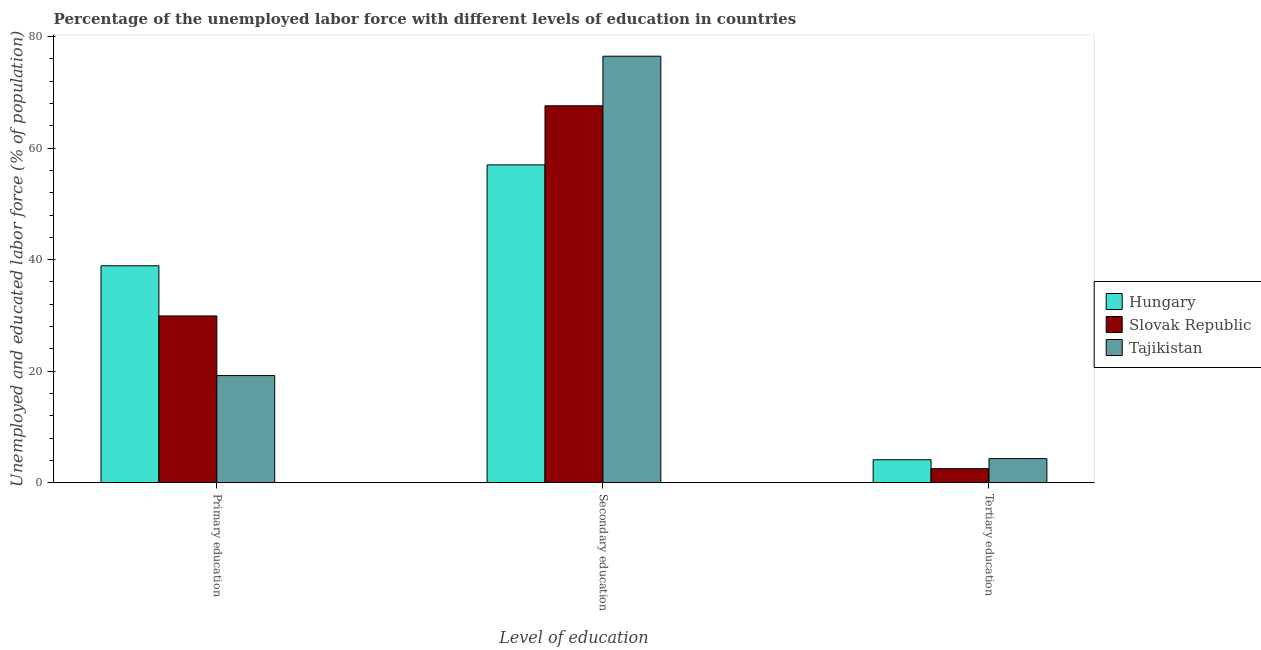Are the number of bars on each tick of the X-axis equal?
Provide a succinct answer. Yes. How many bars are there on the 2nd tick from the left?
Give a very brief answer. 3. How many bars are there on the 2nd tick from the right?
Give a very brief answer. 3. What is the label of the 1st group of bars from the left?
Provide a succinct answer. Primary education. What is the percentage of labor force who received primary education in Tajikistan?
Make the answer very short. 19.2. Across all countries, what is the maximum percentage of labor force who received primary education?
Make the answer very short. 38.9. Across all countries, what is the minimum percentage of labor force who received tertiary education?
Provide a short and direct response. 2.5. In which country was the percentage of labor force who received primary education maximum?
Your answer should be compact. Hungary. In which country was the percentage of labor force who received secondary education minimum?
Make the answer very short. Hungary. What is the total percentage of labor force who received secondary education in the graph?
Offer a terse response. 201.1. What is the difference between the percentage of labor force who received primary education in Hungary and that in Slovak Republic?
Your answer should be compact. 9. What is the difference between the percentage of labor force who received tertiary education in Slovak Republic and the percentage of labor force who received secondary education in Hungary?
Offer a terse response. -54.5. What is the average percentage of labor force who received tertiary education per country?
Your answer should be compact. 3.63. What is the difference between the percentage of labor force who received tertiary education and percentage of labor force who received secondary education in Hungary?
Offer a very short reply. -52.9. In how many countries, is the percentage of labor force who received tertiary education greater than 48 %?
Provide a short and direct response. 0. What is the ratio of the percentage of labor force who received tertiary education in Tajikistan to that in Hungary?
Your response must be concise. 1.05. Is the percentage of labor force who received tertiary education in Tajikistan less than that in Slovak Republic?
Your answer should be very brief. No. Is the difference between the percentage of labor force who received tertiary education in Tajikistan and Slovak Republic greater than the difference between the percentage of labor force who received primary education in Tajikistan and Slovak Republic?
Your answer should be compact. Yes. What is the difference between the highest and the second highest percentage of labor force who received secondary education?
Provide a short and direct response. 8.9. What is the difference between the highest and the lowest percentage of labor force who received primary education?
Your response must be concise. 19.7. Is the sum of the percentage of labor force who received primary education in Hungary and Slovak Republic greater than the maximum percentage of labor force who received tertiary education across all countries?
Provide a short and direct response. Yes. What does the 1st bar from the left in Secondary education represents?
Make the answer very short. Hungary. What does the 1st bar from the right in Tertiary education represents?
Your response must be concise. Tajikistan. How many countries are there in the graph?
Provide a short and direct response. 3. Does the graph contain any zero values?
Your response must be concise. No. Where does the legend appear in the graph?
Make the answer very short. Center right. How many legend labels are there?
Provide a succinct answer. 3. What is the title of the graph?
Give a very brief answer. Percentage of the unemployed labor force with different levels of education in countries. What is the label or title of the X-axis?
Your answer should be very brief. Level of education. What is the label or title of the Y-axis?
Offer a terse response. Unemployed and educated labor force (% of population). What is the Unemployed and educated labor force (% of population) in Hungary in Primary education?
Give a very brief answer. 38.9. What is the Unemployed and educated labor force (% of population) of Slovak Republic in Primary education?
Make the answer very short. 29.9. What is the Unemployed and educated labor force (% of population) of Tajikistan in Primary education?
Your response must be concise. 19.2. What is the Unemployed and educated labor force (% of population) in Slovak Republic in Secondary education?
Provide a short and direct response. 67.6. What is the Unemployed and educated labor force (% of population) in Tajikistan in Secondary education?
Offer a very short reply. 76.5. What is the Unemployed and educated labor force (% of population) in Hungary in Tertiary education?
Your response must be concise. 4.1. What is the Unemployed and educated labor force (% of population) in Tajikistan in Tertiary education?
Offer a terse response. 4.3. Across all Level of education, what is the maximum Unemployed and educated labor force (% of population) of Slovak Republic?
Offer a terse response. 67.6. Across all Level of education, what is the maximum Unemployed and educated labor force (% of population) in Tajikistan?
Offer a very short reply. 76.5. Across all Level of education, what is the minimum Unemployed and educated labor force (% of population) of Hungary?
Give a very brief answer. 4.1. Across all Level of education, what is the minimum Unemployed and educated labor force (% of population) in Tajikistan?
Provide a succinct answer. 4.3. What is the total Unemployed and educated labor force (% of population) of Hungary in the graph?
Make the answer very short. 100. What is the total Unemployed and educated labor force (% of population) of Slovak Republic in the graph?
Offer a very short reply. 100. What is the difference between the Unemployed and educated labor force (% of population) of Hungary in Primary education and that in Secondary education?
Ensure brevity in your answer.  -18.1. What is the difference between the Unemployed and educated labor force (% of population) in Slovak Republic in Primary education and that in Secondary education?
Provide a short and direct response. -37.7. What is the difference between the Unemployed and educated labor force (% of population) in Tajikistan in Primary education and that in Secondary education?
Your answer should be compact. -57.3. What is the difference between the Unemployed and educated labor force (% of population) of Hungary in Primary education and that in Tertiary education?
Your answer should be very brief. 34.8. What is the difference between the Unemployed and educated labor force (% of population) in Slovak Republic in Primary education and that in Tertiary education?
Your answer should be compact. 27.4. What is the difference between the Unemployed and educated labor force (% of population) in Tajikistan in Primary education and that in Tertiary education?
Give a very brief answer. 14.9. What is the difference between the Unemployed and educated labor force (% of population) in Hungary in Secondary education and that in Tertiary education?
Give a very brief answer. 52.9. What is the difference between the Unemployed and educated labor force (% of population) in Slovak Republic in Secondary education and that in Tertiary education?
Offer a terse response. 65.1. What is the difference between the Unemployed and educated labor force (% of population) in Tajikistan in Secondary education and that in Tertiary education?
Provide a short and direct response. 72.2. What is the difference between the Unemployed and educated labor force (% of population) in Hungary in Primary education and the Unemployed and educated labor force (% of population) in Slovak Republic in Secondary education?
Give a very brief answer. -28.7. What is the difference between the Unemployed and educated labor force (% of population) of Hungary in Primary education and the Unemployed and educated labor force (% of population) of Tajikistan in Secondary education?
Make the answer very short. -37.6. What is the difference between the Unemployed and educated labor force (% of population) of Slovak Republic in Primary education and the Unemployed and educated labor force (% of population) of Tajikistan in Secondary education?
Your answer should be very brief. -46.6. What is the difference between the Unemployed and educated labor force (% of population) in Hungary in Primary education and the Unemployed and educated labor force (% of population) in Slovak Republic in Tertiary education?
Offer a terse response. 36.4. What is the difference between the Unemployed and educated labor force (% of population) in Hungary in Primary education and the Unemployed and educated labor force (% of population) in Tajikistan in Tertiary education?
Your response must be concise. 34.6. What is the difference between the Unemployed and educated labor force (% of population) in Slovak Republic in Primary education and the Unemployed and educated labor force (% of population) in Tajikistan in Tertiary education?
Offer a very short reply. 25.6. What is the difference between the Unemployed and educated labor force (% of population) in Hungary in Secondary education and the Unemployed and educated labor force (% of population) in Slovak Republic in Tertiary education?
Ensure brevity in your answer.  54.5. What is the difference between the Unemployed and educated labor force (% of population) of Hungary in Secondary education and the Unemployed and educated labor force (% of population) of Tajikistan in Tertiary education?
Your answer should be very brief. 52.7. What is the difference between the Unemployed and educated labor force (% of population) in Slovak Republic in Secondary education and the Unemployed and educated labor force (% of population) in Tajikistan in Tertiary education?
Offer a very short reply. 63.3. What is the average Unemployed and educated labor force (% of population) in Hungary per Level of education?
Provide a short and direct response. 33.33. What is the average Unemployed and educated labor force (% of population) of Slovak Republic per Level of education?
Your answer should be very brief. 33.33. What is the average Unemployed and educated labor force (% of population) in Tajikistan per Level of education?
Offer a terse response. 33.33. What is the difference between the Unemployed and educated labor force (% of population) in Hungary and Unemployed and educated labor force (% of population) in Slovak Republic in Primary education?
Provide a succinct answer. 9. What is the difference between the Unemployed and educated labor force (% of population) of Slovak Republic and Unemployed and educated labor force (% of population) of Tajikistan in Primary education?
Keep it short and to the point. 10.7. What is the difference between the Unemployed and educated labor force (% of population) in Hungary and Unemployed and educated labor force (% of population) in Slovak Republic in Secondary education?
Keep it short and to the point. -10.6. What is the difference between the Unemployed and educated labor force (% of population) in Hungary and Unemployed and educated labor force (% of population) in Tajikistan in Secondary education?
Offer a terse response. -19.5. What is the difference between the Unemployed and educated labor force (% of population) in Slovak Republic and Unemployed and educated labor force (% of population) in Tajikistan in Secondary education?
Ensure brevity in your answer.  -8.9. What is the difference between the Unemployed and educated labor force (% of population) in Hungary and Unemployed and educated labor force (% of population) in Slovak Republic in Tertiary education?
Your answer should be compact. 1.6. What is the difference between the Unemployed and educated labor force (% of population) of Hungary and Unemployed and educated labor force (% of population) of Tajikistan in Tertiary education?
Your answer should be very brief. -0.2. What is the difference between the Unemployed and educated labor force (% of population) of Slovak Republic and Unemployed and educated labor force (% of population) of Tajikistan in Tertiary education?
Offer a terse response. -1.8. What is the ratio of the Unemployed and educated labor force (% of population) of Hungary in Primary education to that in Secondary education?
Your answer should be compact. 0.68. What is the ratio of the Unemployed and educated labor force (% of population) in Slovak Republic in Primary education to that in Secondary education?
Provide a succinct answer. 0.44. What is the ratio of the Unemployed and educated labor force (% of population) of Tajikistan in Primary education to that in Secondary education?
Provide a succinct answer. 0.25. What is the ratio of the Unemployed and educated labor force (% of population) in Hungary in Primary education to that in Tertiary education?
Make the answer very short. 9.49. What is the ratio of the Unemployed and educated labor force (% of population) in Slovak Republic in Primary education to that in Tertiary education?
Ensure brevity in your answer.  11.96. What is the ratio of the Unemployed and educated labor force (% of population) of Tajikistan in Primary education to that in Tertiary education?
Your answer should be compact. 4.47. What is the ratio of the Unemployed and educated labor force (% of population) in Hungary in Secondary education to that in Tertiary education?
Offer a very short reply. 13.9. What is the ratio of the Unemployed and educated labor force (% of population) of Slovak Republic in Secondary education to that in Tertiary education?
Ensure brevity in your answer.  27.04. What is the ratio of the Unemployed and educated labor force (% of population) in Tajikistan in Secondary education to that in Tertiary education?
Offer a very short reply. 17.79. What is the difference between the highest and the second highest Unemployed and educated labor force (% of population) of Slovak Republic?
Provide a short and direct response. 37.7. What is the difference between the highest and the second highest Unemployed and educated labor force (% of population) of Tajikistan?
Give a very brief answer. 57.3. What is the difference between the highest and the lowest Unemployed and educated labor force (% of population) in Hungary?
Make the answer very short. 52.9. What is the difference between the highest and the lowest Unemployed and educated labor force (% of population) of Slovak Republic?
Your response must be concise. 65.1. What is the difference between the highest and the lowest Unemployed and educated labor force (% of population) of Tajikistan?
Make the answer very short. 72.2. 